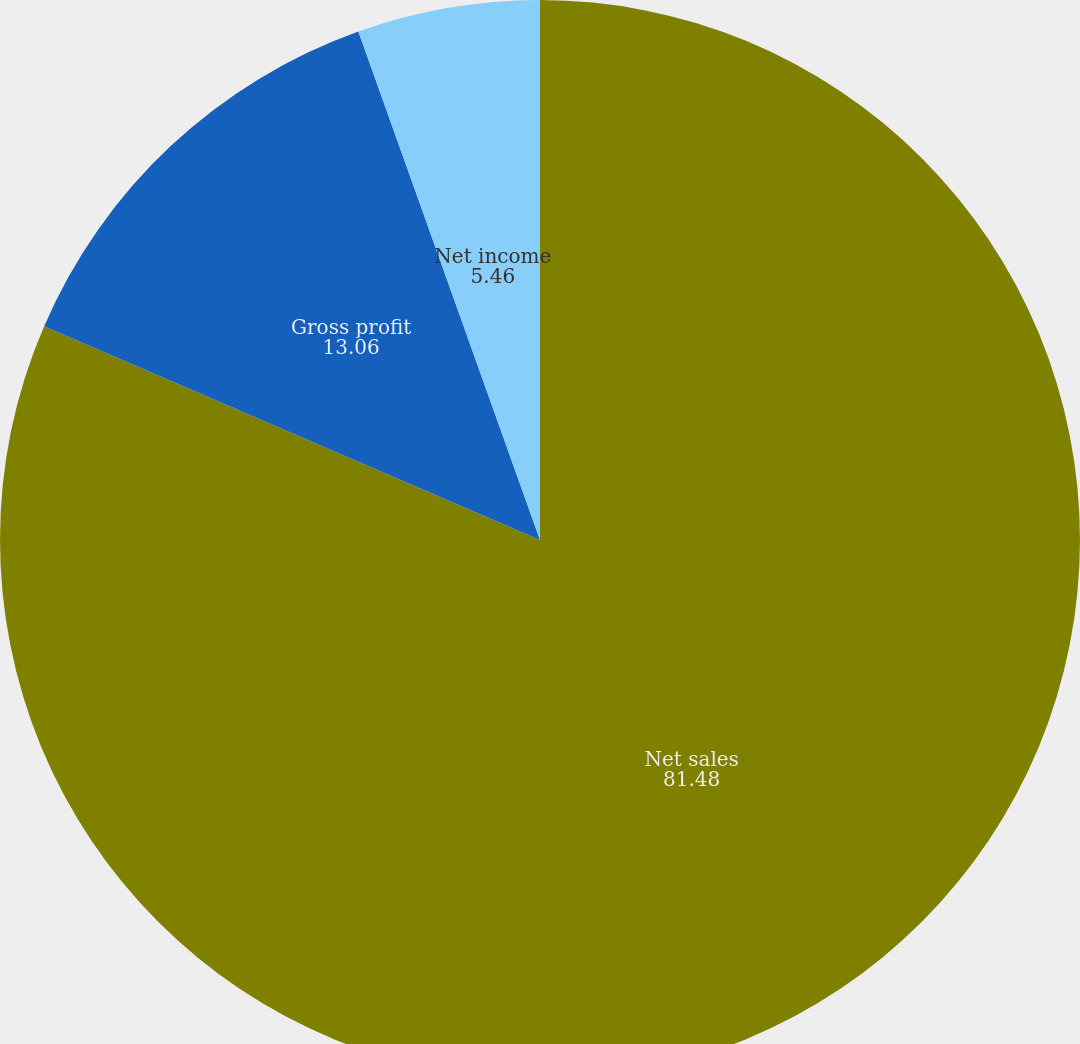Convert chart to OTSL. <chart><loc_0><loc_0><loc_500><loc_500><pie_chart><fcel>Net sales<fcel>Gross profit<fcel>Net income<nl><fcel>81.48%<fcel>13.06%<fcel>5.46%<nl></chart> 